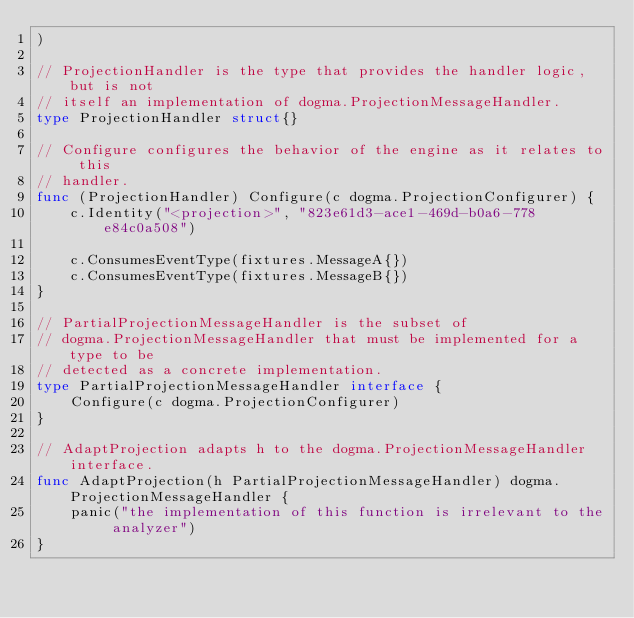<code> <loc_0><loc_0><loc_500><loc_500><_Go_>)

// ProjectionHandler is the type that provides the handler logic, but is not
// itself an implementation of dogma.ProjectionMessageHandler.
type ProjectionHandler struct{}

// Configure configures the behavior of the engine as it relates to this
// handler.
func (ProjectionHandler) Configure(c dogma.ProjectionConfigurer) {
	c.Identity("<projection>", "823e61d3-ace1-469d-b0a6-778e84c0a508")

	c.ConsumesEventType(fixtures.MessageA{})
	c.ConsumesEventType(fixtures.MessageB{})
}

// PartialProjectionMessageHandler is the subset of
// dogma.ProjectionMessageHandler that must be implemented for a type to be
// detected as a concrete implementation.
type PartialProjectionMessageHandler interface {
	Configure(c dogma.ProjectionConfigurer)
}

// AdaptProjection adapts h to the dogma.ProjectionMessageHandler interface.
func AdaptProjection(h PartialProjectionMessageHandler) dogma.ProjectionMessageHandler {
	panic("the implementation of this function is irrelevant to the analyzer")
}
</code> 